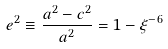Convert formula to latex. <formula><loc_0><loc_0><loc_500><loc_500>e ^ { 2 } \equiv \frac { a ^ { 2 } - c ^ { 2 } } { a ^ { 2 } } = 1 - \xi ^ { - 6 }</formula> 